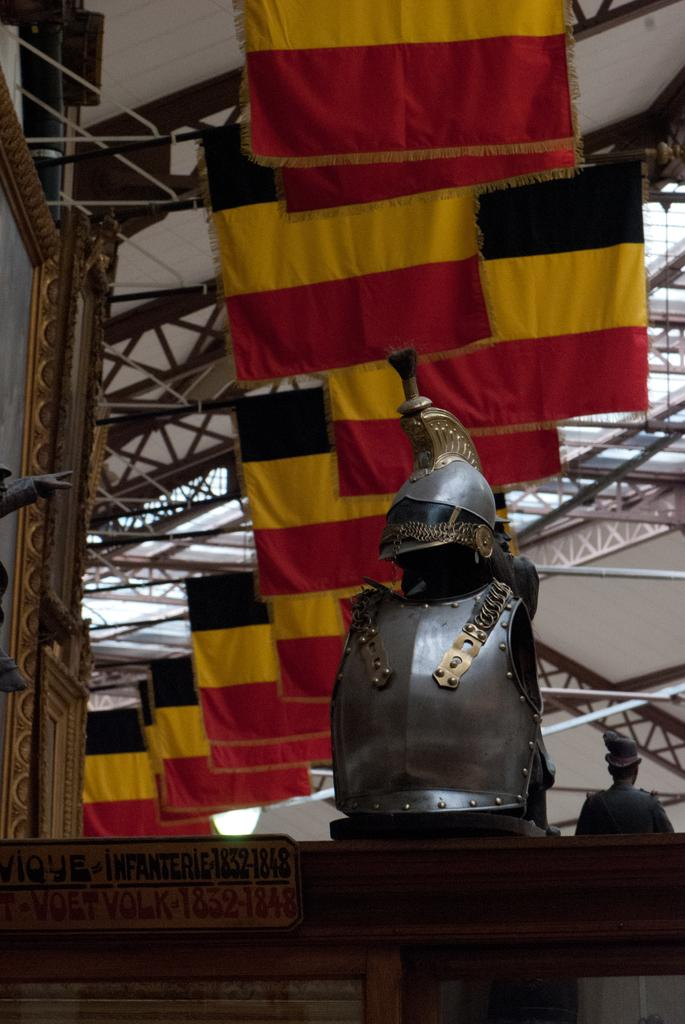What type of object is present in the image? There is an Armour in the image. What other items can be seen in the image? There are flags, metal rods extending to the ceiling, a statue, and a light in the image. Is there any quicksand visible in the image? No, there is no quicksand present in the image. What type of wrist accessory can be seen on the statue in the image? There is no wrist accessory visible on the statue in the image. 